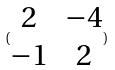<formula> <loc_0><loc_0><loc_500><loc_500>( \begin{matrix} 2 & - 4 \\ - 1 & 2 \end{matrix} )</formula> 